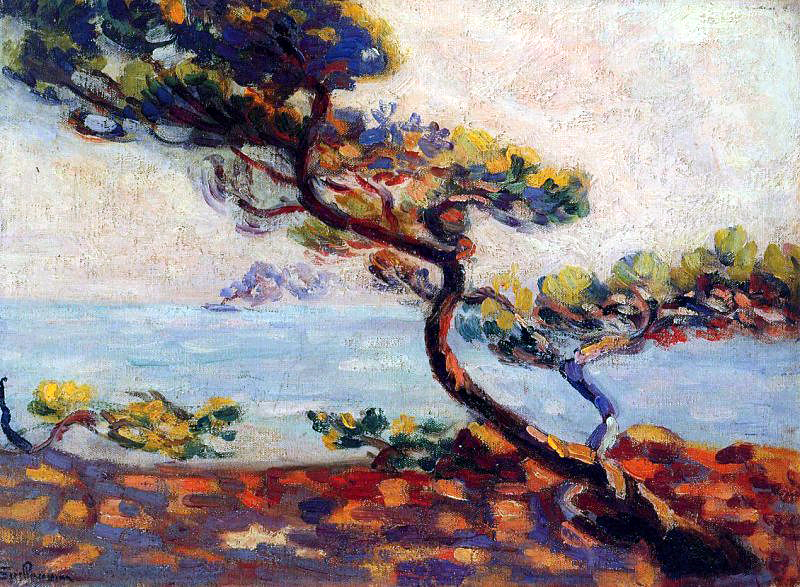What kind of music would best accompany this painting? A gentle and calming piece of classical music would best accompany this painting. Something like Claude Debussy's 'Clair de Lune' would enhance the tranquil and reflective nature of the scene, with its soft, flowing melodies mirroring the fluid brushstrokes and serene seascape. 